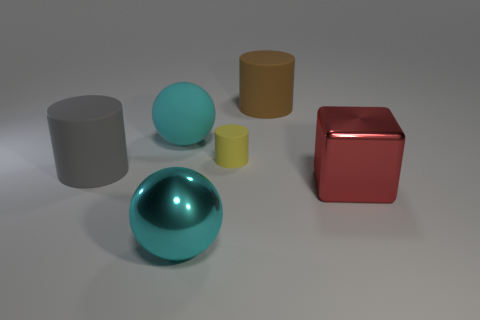Add 1 tiny metallic cylinders. How many objects exist? 7 Subtract all balls. How many objects are left? 4 Subtract 0 green cylinders. How many objects are left? 6 Subtract all large gray cylinders. Subtract all big red metallic cubes. How many objects are left? 4 Add 3 cyan metal things. How many cyan metal things are left? 4 Add 6 cyan rubber spheres. How many cyan rubber spheres exist? 7 